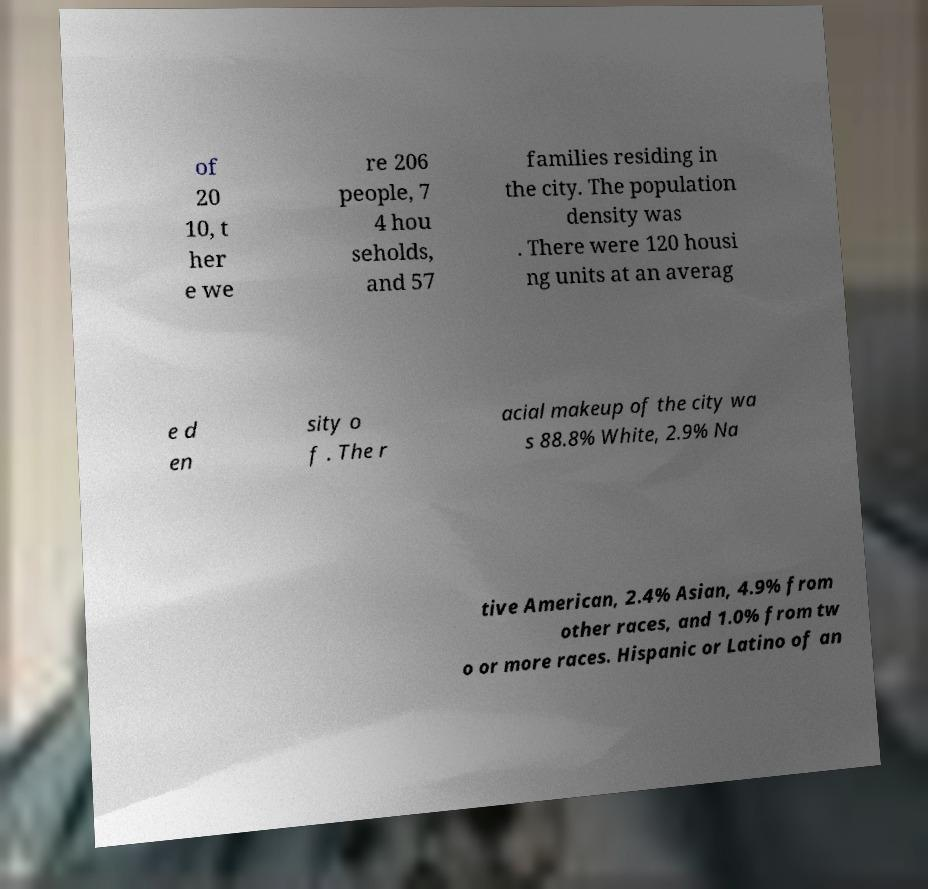For documentation purposes, I need the text within this image transcribed. Could you provide that? of 20 10, t her e we re 206 people, 7 4 hou seholds, and 57 families residing in the city. The population density was . There were 120 housi ng units at an averag e d en sity o f . The r acial makeup of the city wa s 88.8% White, 2.9% Na tive American, 2.4% Asian, 4.9% from other races, and 1.0% from tw o or more races. Hispanic or Latino of an 